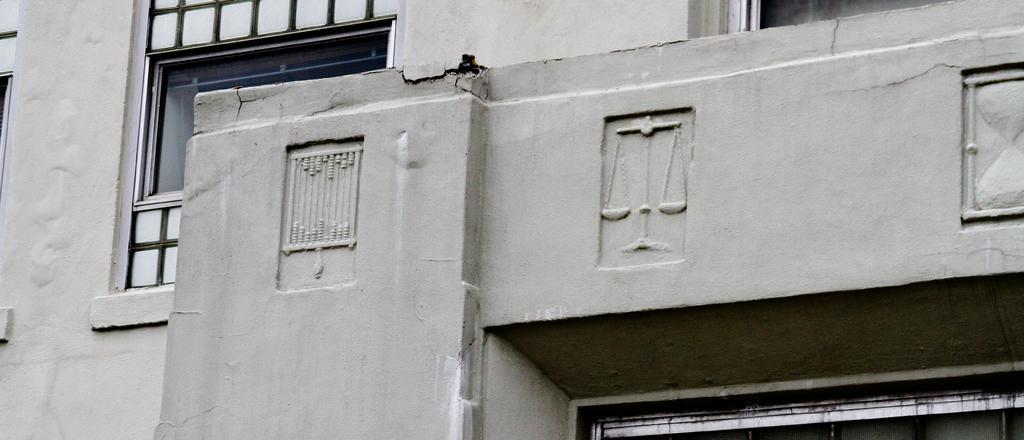Describe this image in one or two sentences. In this image in the front there is a wall. In the background there are windows. 